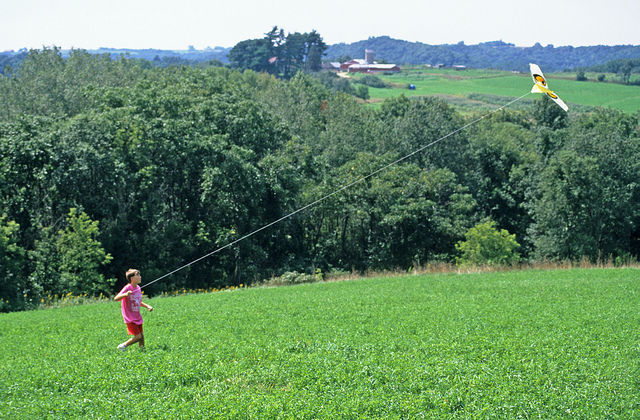How do the surroundings impact the child's outdoor activities? The serene and spacious surroundings significantly enhance the child’s outdoor activities. The grassy hill provides ample room for running and playing, the fresh air and greenery contribute to a sense of freedom and well-being, and the peaceful environment away from the hustle and bustle of town fosters a safe and enjoyable space for activities like kite flying. The natural setting encourages exploration and physical activity while also promoting relaxation and creativity. 